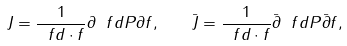Convert formula to latex. <formula><loc_0><loc_0><loc_500><loc_500>J = \frac { 1 } { \ f d \cdot f } \partial \ f d P \partial f , \quad \bar { J } = \frac { 1 } { \ f d \cdot f } \bar { \partial } \ f d P \bar { \partial } f ,</formula> 